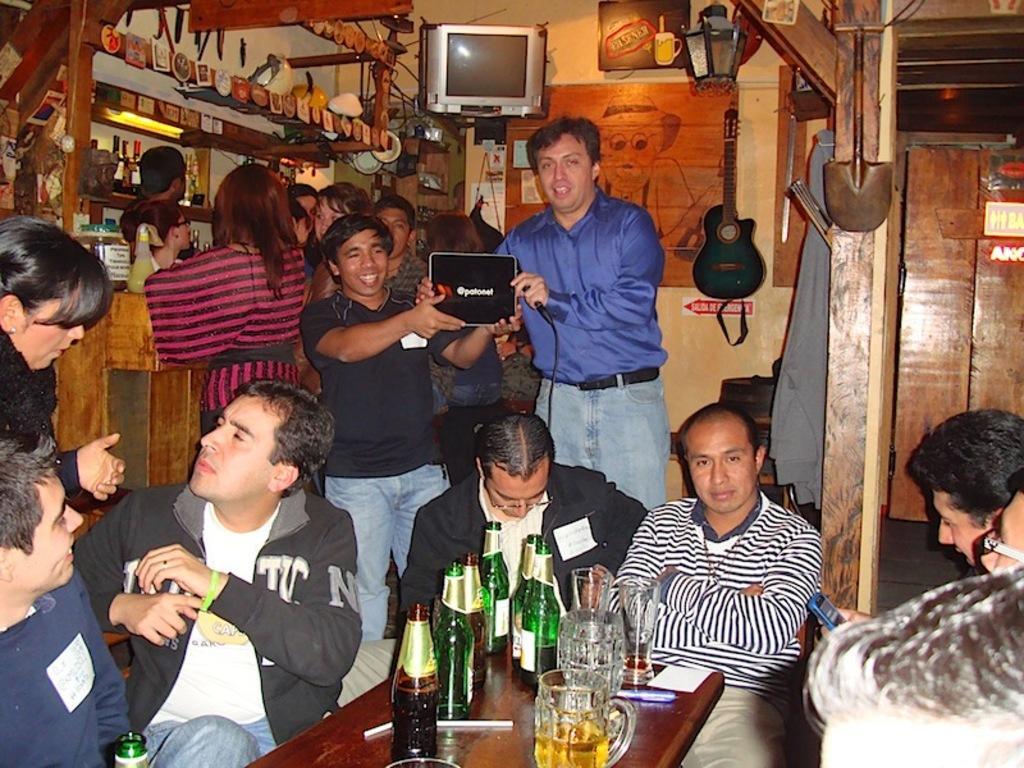Can you describe this image briefly? Inside a club there are group of people sitting around the table, there are many alcohol bottles and glasses kept on the table and on the left side there are plenty of alcohols kept in the shelves and the people are standing in front of the table and there is a television fixed to the wall on the right side and there is a guitar beside the television and in the middle two men were standing and holding some object with their hands. 